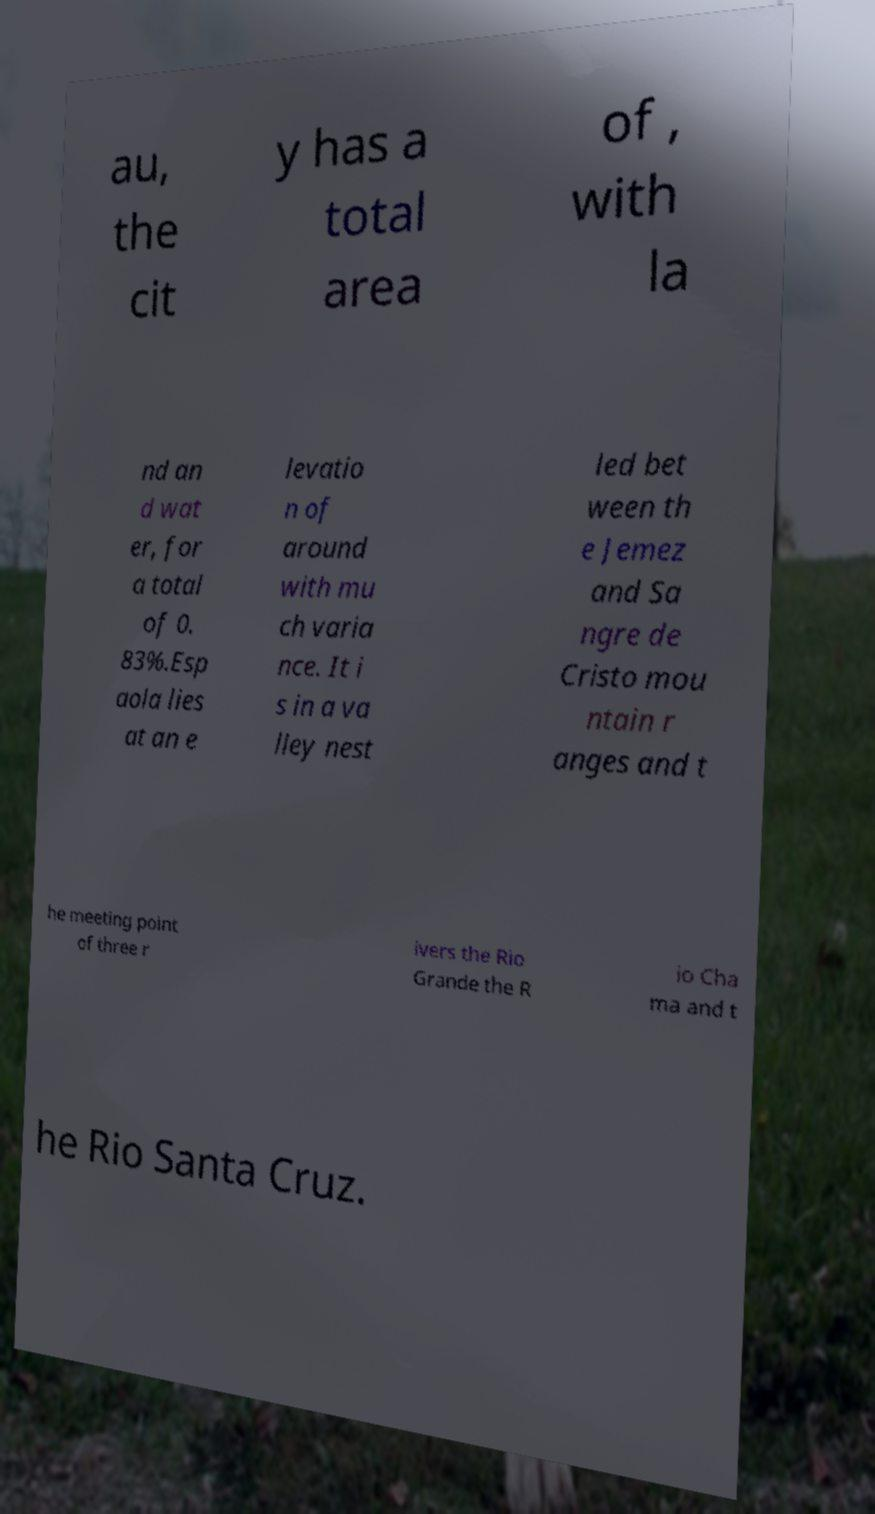Could you extract and type out the text from this image? au, the cit y has a total area of , with la nd an d wat er, for a total of 0. 83%.Esp aola lies at an e levatio n of around with mu ch varia nce. It i s in a va lley nest led bet ween th e Jemez and Sa ngre de Cristo mou ntain r anges and t he meeting point of three r ivers the Rio Grande the R io Cha ma and t he Rio Santa Cruz. 